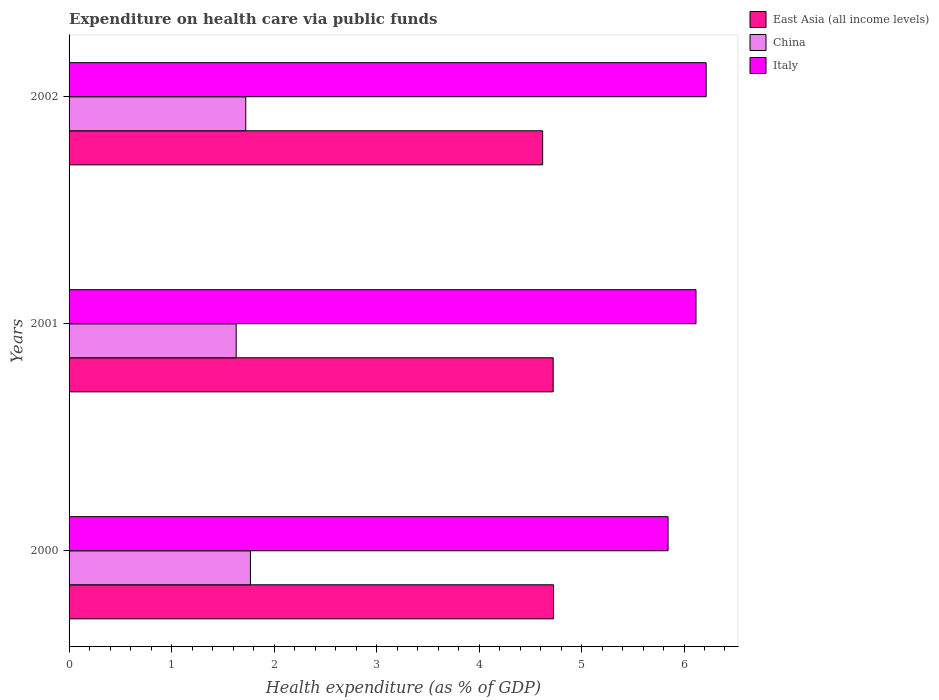How many different coloured bars are there?
Your response must be concise. 3. Are the number of bars per tick equal to the number of legend labels?
Provide a succinct answer. Yes. How many bars are there on the 1st tick from the top?
Your answer should be very brief. 3. In how many cases, is the number of bars for a given year not equal to the number of legend labels?
Provide a succinct answer. 0. What is the expenditure made on health care in China in 2000?
Give a very brief answer. 1.77. Across all years, what is the maximum expenditure made on health care in East Asia (all income levels)?
Your answer should be very brief. 4.73. Across all years, what is the minimum expenditure made on health care in East Asia (all income levels)?
Make the answer very short. 4.62. In which year was the expenditure made on health care in China maximum?
Make the answer very short. 2000. What is the total expenditure made on health care in Italy in the graph?
Give a very brief answer. 18.18. What is the difference between the expenditure made on health care in Italy in 2001 and that in 2002?
Ensure brevity in your answer.  -0.1. What is the difference between the expenditure made on health care in Italy in 2000 and the expenditure made on health care in East Asia (all income levels) in 2001?
Keep it short and to the point. 1.12. What is the average expenditure made on health care in East Asia (all income levels) per year?
Offer a terse response. 4.69. In the year 2002, what is the difference between the expenditure made on health care in East Asia (all income levels) and expenditure made on health care in China?
Give a very brief answer. 2.9. In how many years, is the expenditure made on health care in Italy greater than 6.2 %?
Provide a succinct answer. 1. What is the ratio of the expenditure made on health care in Italy in 2000 to that in 2001?
Provide a short and direct response. 0.96. What is the difference between the highest and the second highest expenditure made on health care in China?
Keep it short and to the point. 0.05. What is the difference between the highest and the lowest expenditure made on health care in Italy?
Provide a succinct answer. 0.37. Is the sum of the expenditure made on health care in China in 2000 and 2001 greater than the maximum expenditure made on health care in East Asia (all income levels) across all years?
Your answer should be compact. No. What does the 2nd bar from the top in 2001 represents?
Make the answer very short. China. What does the 1st bar from the bottom in 2002 represents?
Provide a succinct answer. East Asia (all income levels). Is it the case that in every year, the sum of the expenditure made on health care in East Asia (all income levels) and expenditure made on health care in China is greater than the expenditure made on health care in Italy?
Your answer should be compact. Yes. Are all the bars in the graph horizontal?
Ensure brevity in your answer.  Yes. Are the values on the major ticks of X-axis written in scientific E-notation?
Offer a terse response. No. Does the graph contain any zero values?
Keep it short and to the point. No. Where does the legend appear in the graph?
Give a very brief answer. Top right. How many legend labels are there?
Offer a terse response. 3. How are the legend labels stacked?
Keep it short and to the point. Vertical. What is the title of the graph?
Your answer should be compact. Expenditure on health care via public funds. What is the label or title of the X-axis?
Offer a very short reply. Health expenditure (as % of GDP). What is the label or title of the Y-axis?
Provide a succinct answer. Years. What is the Health expenditure (as % of GDP) of East Asia (all income levels) in 2000?
Make the answer very short. 4.73. What is the Health expenditure (as % of GDP) in China in 2000?
Your response must be concise. 1.77. What is the Health expenditure (as % of GDP) of Italy in 2000?
Ensure brevity in your answer.  5.84. What is the Health expenditure (as % of GDP) of East Asia (all income levels) in 2001?
Provide a succinct answer. 4.72. What is the Health expenditure (as % of GDP) in China in 2001?
Ensure brevity in your answer.  1.63. What is the Health expenditure (as % of GDP) of Italy in 2001?
Your answer should be very brief. 6.12. What is the Health expenditure (as % of GDP) in East Asia (all income levels) in 2002?
Give a very brief answer. 4.62. What is the Health expenditure (as % of GDP) in China in 2002?
Give a very brief answer. 1.72. What is the Health expenditure (as % of GDP) of Italy in 2002?
Make the answer very short. 6.22. Across all years, what is the maximum Health expenditure (as % of GDP) in East Asia (all income levels)?
Your answer should be very brief. 4.73. Across all years, what is the maximum Health expenditure (as % of GDP) of China?
Keep it short and to the point. 1.77. Across all years, what is the maximum Health expenditure (as % of GDP) in Italy?
Keep it short and to the point. 6.22. Across all years, what is the minimum Health expenditure (as % of GDP) of East Asia (all income levels)?
Your answer should be very brief. 4.62. Across all years, what is the minimum Health expenditure (as % of GDP) in China?
Make the answer very short. 1.63. Across all years, what is the minimum Health expenditure (as % of GDP) in Italy?
Offer a terse response. 5.84. What is the total Health expenditure (as % of GDP) of East Asia (all income levels) in the graph?
Keep it short and to the point. 14.07. What is the total Health expenditure (as % of GDP) in China in the graph?
Provide a succinct answer. 5.12. What is the total Health expenditure (as % of GDP) in Italy in the graph?
Your answer should be compact. 18.18. What is the difference between the Health expenditure (as % of GDP) of East Asia (all income levels) in 2000 and that in 2001?
Keep it short and to the point. 0. What is the difference between the Health expenditure (as % of GDP) in China in 2000 and that in 2001?
Make the answer very short. 0.14. What is the difference between the Health expenditure (as % of GDP) of Italy in 2000 and that in 2001?
Your response must be concise. -0.27. What is the difference between the Health expenditure (as % of GDP) of East Asia (all income levels) in 2000 and that in 2002?
Offer a terse response. 0.11. What is the difference between the Health expenditure (as % of GDP) in China in 2000 and that in 2002?
Make the answer very short. 0.05. What is the difference between the Health expenditure (as % of GDP) in Italy in 2000 and that in 2002?
Provide a short and direct response. -0.37. What is the difference between the Health expenditure (as % of GDP) in East Asia (all income levels) in 2001 and that in 2002?
Offer a very short reply. 0.1. What is the difference between the Health expenditure (as % of GDP) of China in 2001 and that in 2002?
Offer a terse response. -0.09. What is the difference between the Health expenditure (as % of GDP) of Italy in 2001 and that in 2002?
Ensure brevity in your answer.  -0.1. What is the difference between the Health expenditure (as % of GDP) in East Asia (all income levels) in 2000 and the Health expenditure (as % of GDP) in China in 2001?
Offer a very short reply. 3.1. What is the difference between the Health expenditure (as % of GDP) in East Asia (all income levels) in 2000 and the Health expenditure (as % of GDP) in Italy in 2001?
Your answer should be compact. -1.39. What is the difference between the Health expenditure (as % of GDP) in China in 2000 and the Health expenditure (as % of GDP) in Italy in 2001?
Your answer should be very brief. -4.35. What is the difference between the Health expenditure (as % of GDP) of East Asia (all income levels) in 2000 and the Health expenditure (as % of GDP) of China in 2002?
Provide a succinct answer. 3. What is the difference between the Health expenditure (as % of GDP) of East Asia (all income levels) in 2000 and the Health expenditure (as % of GDP) of Italy in 2002?
Your answer should be compact. -1.49. What is the difference between the Health expenditure (as % of GDP) in China in 2000 and the Health expenditure (as % of GDP) in Italy in 2002?
Ensure brevity in your answer.  -4.45. What is the difference between the Health expenditure (as % of GDP) in East Asia (all income levels) in 2001 and the Health expenditure (as % of GDP) in China in 2002?
Your answer should be compact. 3. What is the difference between the Health expenditure (as % of GDP) of East Asia (all income levels) in 2001 and the Health expenditure (as % of GDP) of Italy in 2002?
Keep it short and to the point. -1.49. What is the difference between the Health expenditure (as % of GDP) of China in 2001 and the Health expenditure (as % of GDP) of Italy in 2002?
Provide a succinct answer. -4.59. What is the average Health expenditure (as % of GDP) in East Asia (all income levels) per year?
Your answer should be compact. 4.69. What is the average Health expenditure (as % of GDP) in China per year?
Make the answer very short. 1.71. What is the average Health expenditure (as % of GDP) in Italy per year?
Give a very brief answer. 6.06. In the year 2000, what is the difference between the Health expenditure (as % of GDP) of East Asia (all income levels) and Health expenditure (as % of GDP) of China?
Offer a very short reply. 2.96. In the year 2000, what is the difference between the Health expenditure (as % of GDP) of East Asia (all income levels) and Health expenditure (as % of GDP) of Italy?
Offer a very short reply. -1.12. In the year 2000, what is the difference between the Health expenditure (as % of GDP) in China and Health expenditure (as % of GDP) in Italy?
Your response must be concise. -4.07. In the year 2001, what is the difference between the Health expenditure (as % of GDP) of East Asia (all income levels) and Health expenditure (as % of GDP) of China?
Provide a succinct answer. 3.09. In the year 2001, what is the difference between the Health expenditure (as % of GDP) of East Asia (all income levels) and Health expenditure (as % of GDP) of Italy?
Ensure brevity in your answer.  -1.39. In the year 2001, what is the difference between the Health expenditure (as % of GDP) of China and Health expenditure (as % of GDP) of Italy?
Make the answer very short. -4.49. In the year 2002, what is the difference between the Health expenditure (as % of GDP) in East Asia (all income levels) and Health expenditure (as % of GDP) in China?
Ensure brevity in your answer.  2.9. In the year 2002, what is the difference between the Health expenditure (as % of GDP) in East Asia (all income levels) and Health expenditure (as % of GDP) in Italy?
Offer a terse response. -1.6. In the year 2002, what is the difference between the Health expenditure (as % of GDP) of China and Health expenditure (as % of GDP) of Italy?
Provide a short and direct response. -4.49. What is the ratio of the Health expenditure (as % of GDP) of East Asia (all income levels) in 2000 to that in 2001?
Make the answer very short. 1. What is the ratio of the Health expenditure (as % of GDP) in China in 2000 to that in 2001?
Your response must be concise. 1.09. What is the ratio of the Health expenditure (as % of GDP) in Italy in 2000 to that in 2001?
Offer a very short reply. 0.96. What is the ratio of the Health expenditure (as % of GDP) of East Asia (all income levels) in 2000 to that in 2002?
Offer a terse response. 1.02. What is the ratio of the Health expenditure (as % of GDP) in China in 2000 to that in 2002?
Offer a very short reply. 1.03. What is the ratio of the Health expenditure (as % of GDP) in Italy in 2000 to that in 2002?
Your answer should be compact. 0.94. What is the ratio of the Health expenditure (as % of GDP) in East Asia (all income levels) in 2001 to that in 2002?
Provide a short and direct response. 1.02. What is the ratio of the Health expenditure (as % of GDP) of China in 2001 to that in 2002?
Give a very brief answer. 0.95. What is the ratio of the Health expenditure (as % of GDP) of Italy in 2001 to that in 2002?
Provide a succinct answer. 0.98. What is the difference between the highest and the second highest Health expenditure (as % of GDP) in East Asia (all income levels)?
Your answer should be compact. 0. What is the difference between the highest and the second highest Health expenditure (as % of GDP) of China?
Provide a succinct answer. 0.05. What is the difference between the highest and the second highest Health expenditure (as % of GDP) of Italy?
Keep it short and to the point. 0.1. What is the difference between the highest and the lowest Health expenditure (as % of GDP) in East Asia (all income levels)?
Ensure brevity in your answer.  0.11. What is the difference between the highest and the lowest Health expenditure (as % of GDP) of China?
Offer a terse response. 0.14. What is the difference between the highest and the lowest Health expenditure (as % of GDP) in Italy?
Keep it short and to the point. 0.37. 